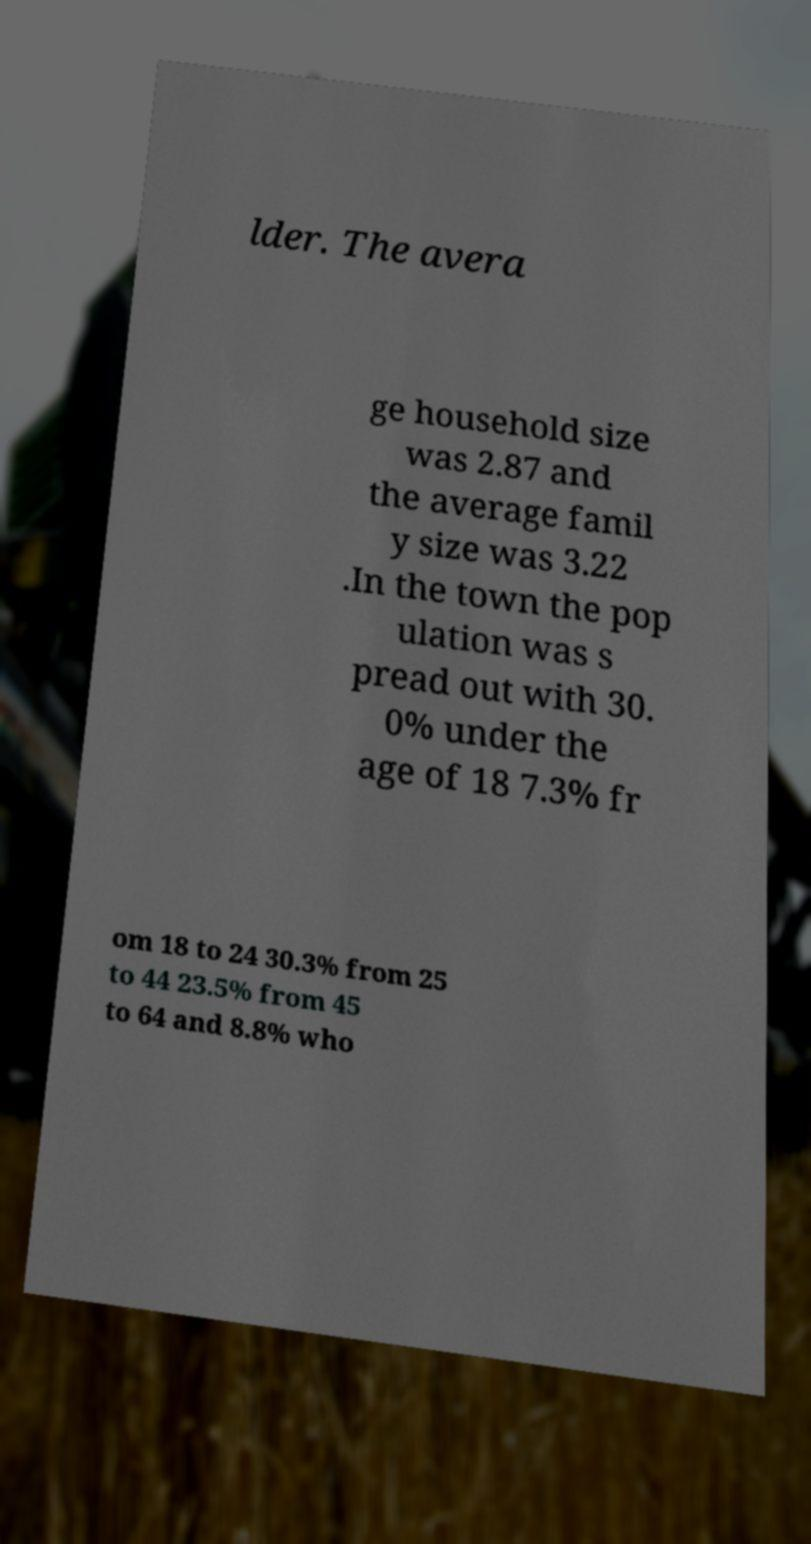I need the written content from this picture converted into text. Can you do that? lder. The avera ge household size was 2.87 and the average famil y size was 3.22 .In the town the pop ulation was s pread out with 30. 0% under the age of 18 7.3% fr om 18 to 24 30.3% from 25 to 44 23.5% from 45 to 64 and 8.8% who 